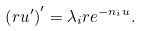Convert formula to latex. <formula><loc_0><loc_0><loc_500><loc_500>\left ( r u ^ { \prime } \right ) ^ { \prime } = \lambda _ { i } r e ^ { - n _ { i } u } .</formula> 